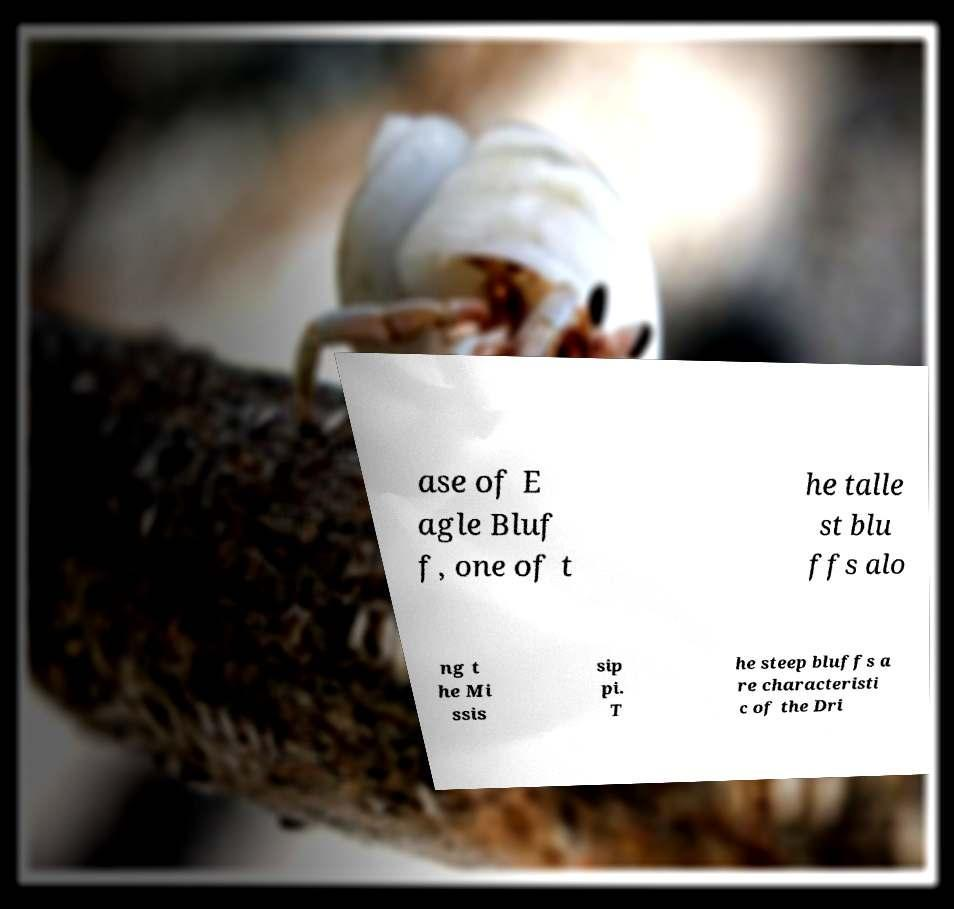For documentation purposes, I need the text within this image transcribed. Could you provide that? ase of E agle Bluf f, one of t he talle st blu ffs alo ng t he Mi ssis sip pi. T he steep bluffs a re characteristi c of the Dri 